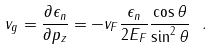Convert formula to latex. <formula><loc_0><loc_0><loc_500><loc_500>v _ { g } = \frac { \partial \epsilon _ { n } } { \partial p _ { z } } = - v _ { F } \frac { \epsilon _ { n } } { 2 E _ { F } } \frac { \cos \theta } { \sin ^ { 2 } \theta } \ .</formula> 